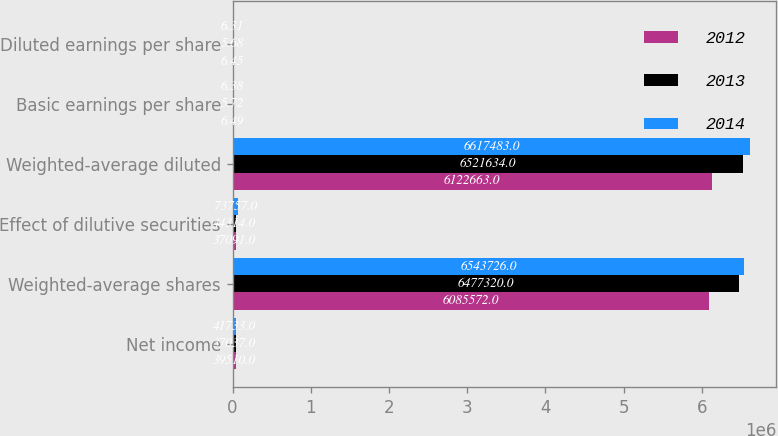<chart> <loc_0><loc_0><loc_500><loc_500><stacked_bar_chart><ecel><fcel>Net income<fcel>Weighted-average shares<fcel>Effect of dilutive securities<fcel>Weighted-average diluted<fcel>Basic earnings per share<fcel>Diluted earnings per share<nl><fcel>2012<fcel>39510<fcel>6.08557e+06<fcel>37091<fcel>6.12266e+06<fcel>6.49<fcel>6.45<nl><fcel>2013<fcel>37037<fcel>6.47732e+06<fcel>44314<fcel>6.52163e+06<fcel>5.72<fcel>5.68<nl><fcel>2014<fcel>41733<fcel>6.54373e+06<fcel>73757<fcel>6.61748e+06<fcel>6.38<fcel>6.31<nl></chart> 